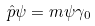Convert formula to latex. <formula><loc_0><loc_0><loc_500><loc_500>\hat { p } \psi = m \psi \gamma _ { 0 }</formula> 